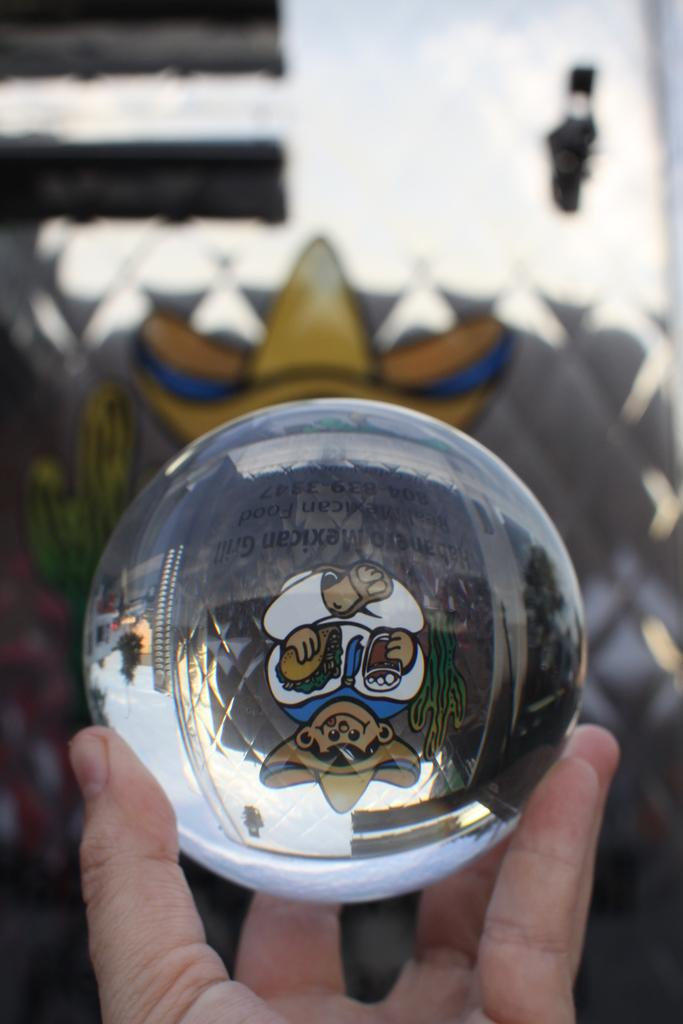What shape is the main object in the image? The main object in the image is a round object. Who is holding the round object? The round object is being held by a person. What can be seen on the round object? There is text and an image on the round object, as well as a reflection of a building. How would you describe the background of the image? The background of the image is blurred. How many chairs are visible in the image? There are no chairs visible in the image; the focus is on the round object being held by a person. 